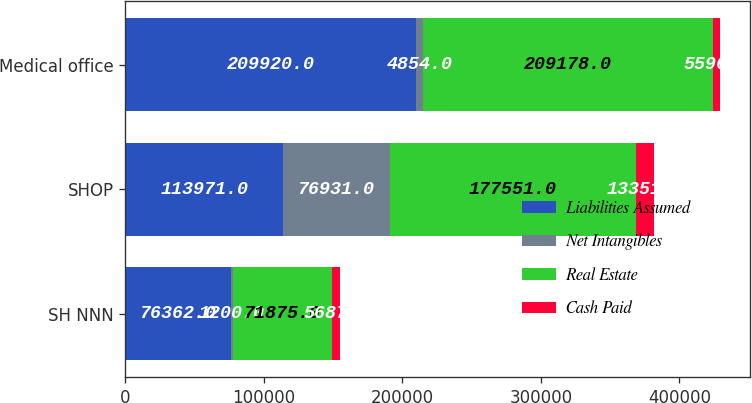Convert chart to OTSL. <chart><loc_0><loc_0><loc_500><loc_500><stacked_bar_chart><ecel><fcel>SH NNN<fcel>SHOP<fcel>Medical office<nl><fcel>Liabilities Assumed<fcel>76362<fcel>113971<fcel>209920<nl><fcel>Net Intangibles<fcel>1200<fcel>76931<fcel>4854<nl><fcel>Real Estate<fcel>71875<fcel>177551<fcel>209178<nl><fcel>Cash Paid<fcel>5687<fcel>13351<fcel>5596<nl></chart> 